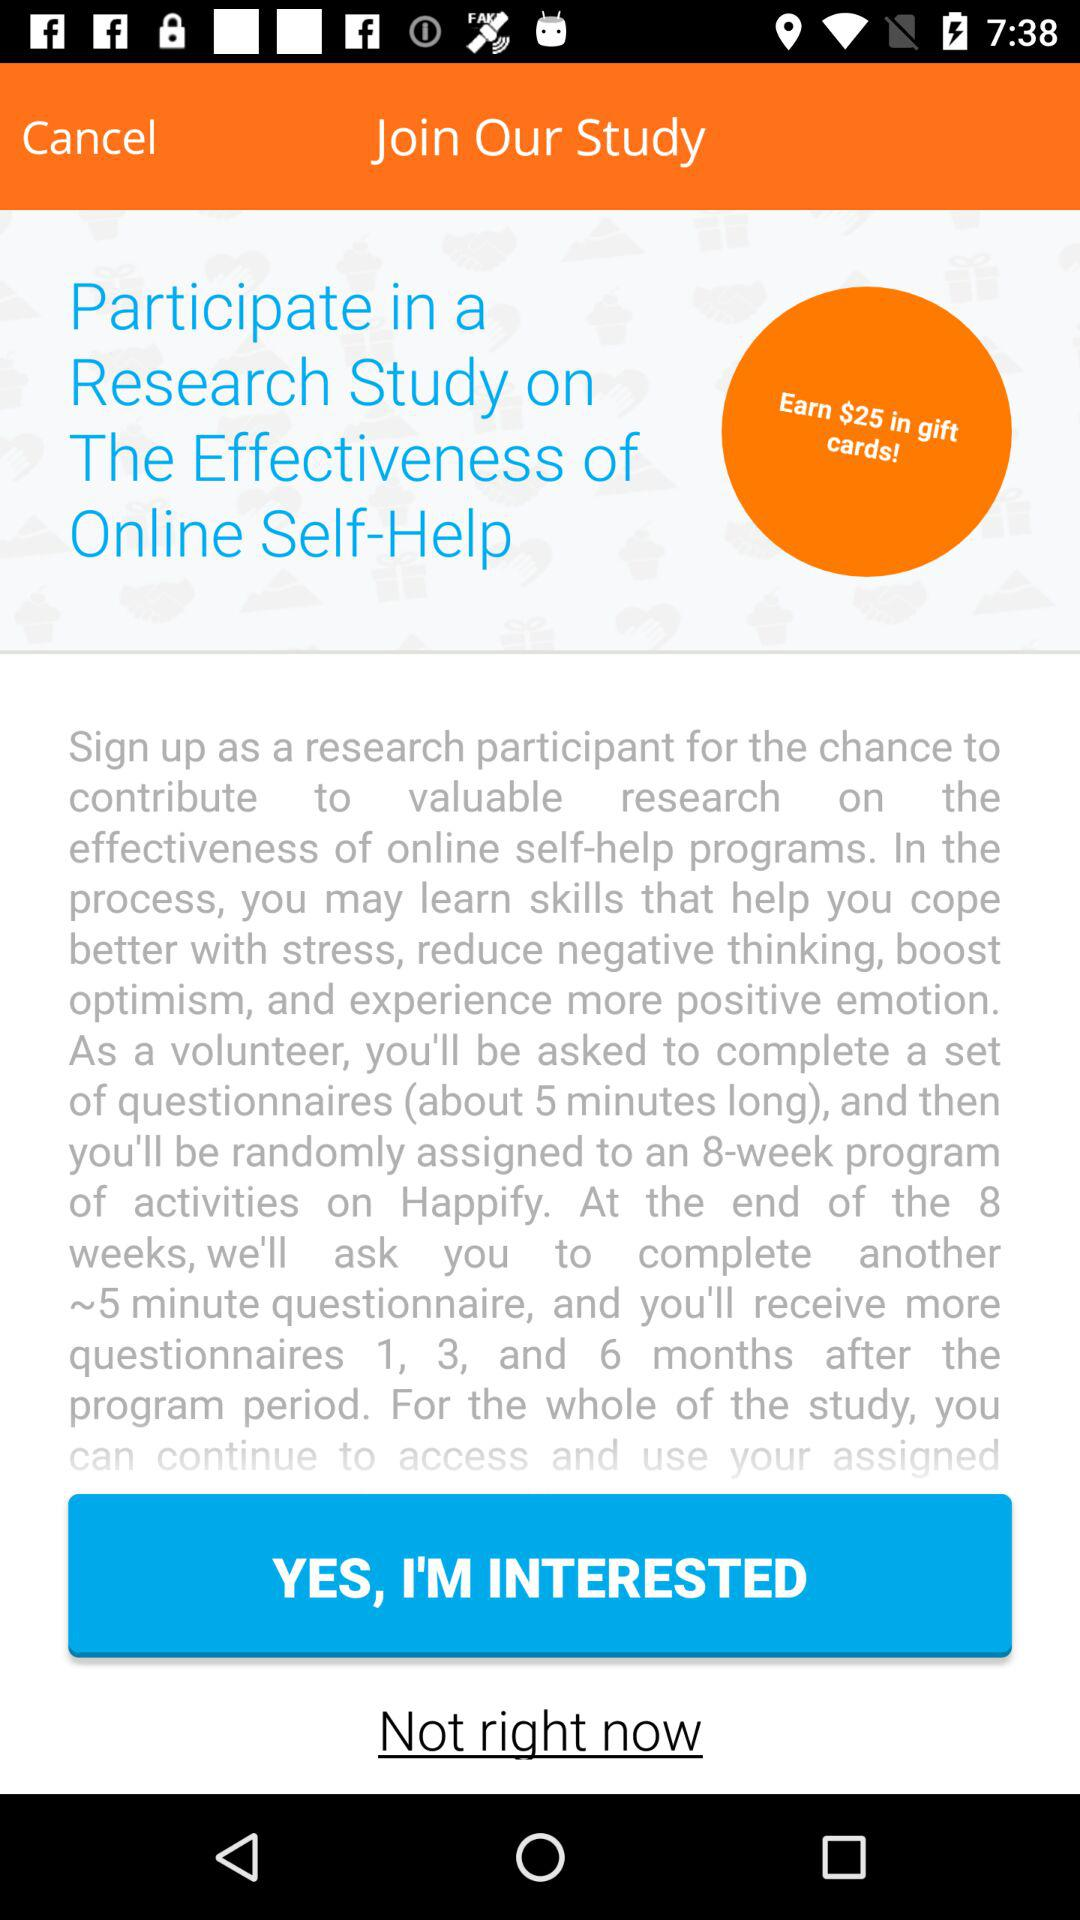What is the duration of the program? The duration of the program is 8 weeks. 